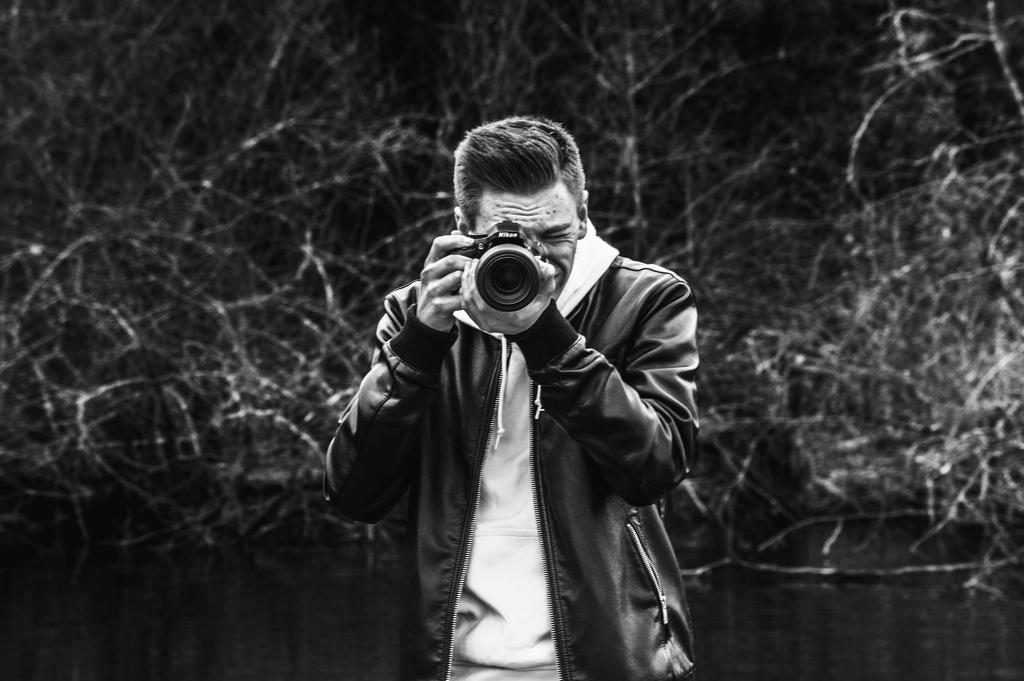In one or two sentences, can you explain what this image depicts? Here we can see a person capturing something with his camera and behind him we can see plants 